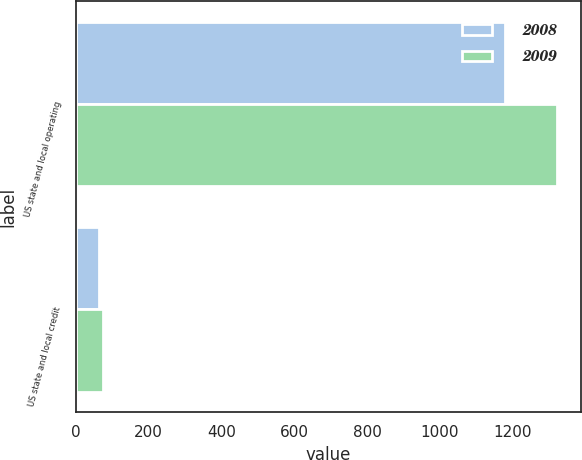<chart> <loc_0><loc_0><loc_500><loc_500><stacked_bar_chart><ecel><fcel>US state and local operating<fcel>US state and local credit<nl><fcel>2008<fcel>1178<fcel>65<nl><fcel>2009<fcel>1320<fcel>74<nl></chart> 